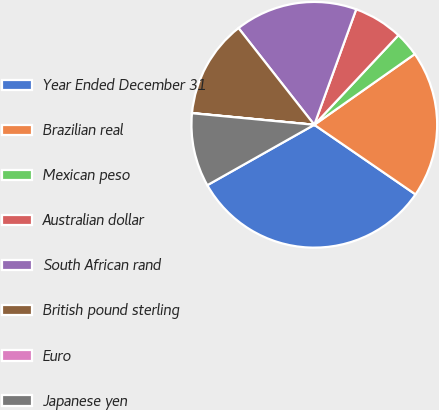Convert chart to OTSL. <chart><loc_0><loc_0><loc_500><loc_500><pie_chart><fcel>Year Ended December 31<fcel>Brazilian real<fcel>Mexican peso<fcel>Australian dollar<fcel>South African rand<fcel>British pound sterling<fcel>Euro<fcel>Japanese yen<nl><fcel>32.23%<fcel>19.35%<fcel>3.24%<fcel>6.46%<fcel>16.12%<fcel>12.9%<fcel>0.02%<fcel>9.68%<nl></chart> 